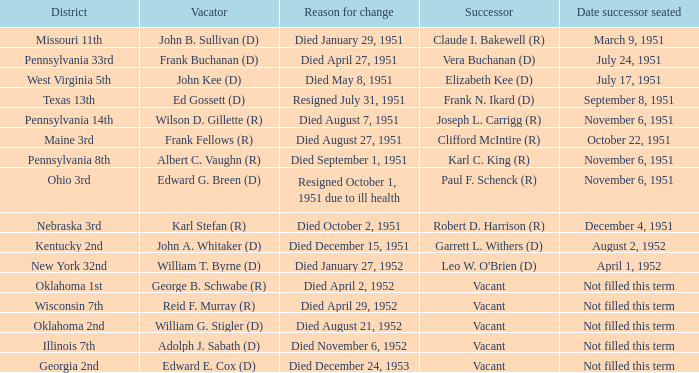What was the number of vacators in the pennsylvania 33rd district? 1.0. 